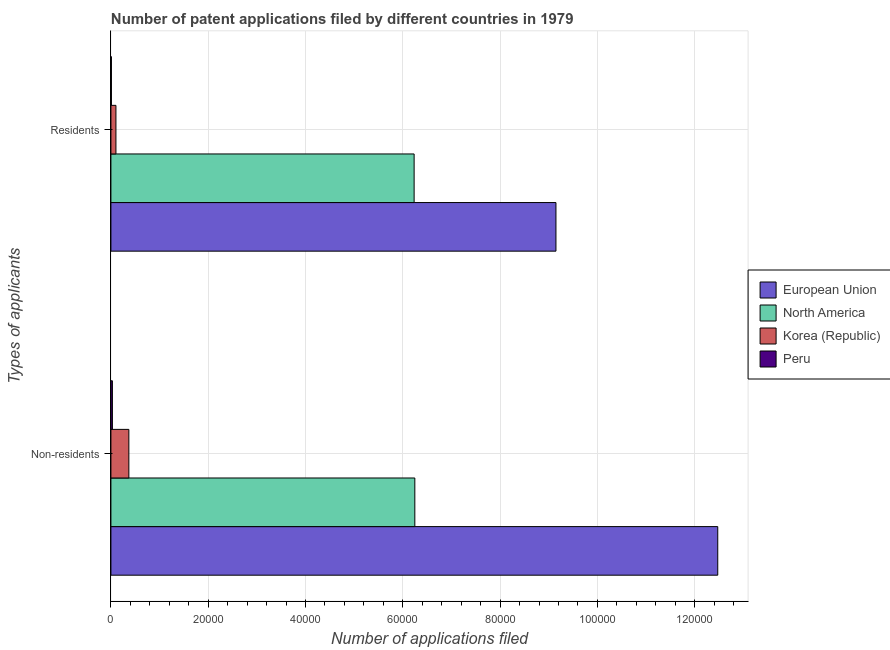Are the number of bars on each tick of the Y-axis equal?
Provide a succinct answer. Yes. How many bars are there on the 2nd tick from the top?
Give a very brief answer. 4. How many bars are there on the 1st tick from the bottom?
Provide a succinct answer. 4. What is the label of the 1st group of bars from the top?
Ensure brevity in your answer.  Residents. What is the number of patent applications by residents in North America?
Ensure brevity in your answer.  6.23e+04. Across all countries, what is the maximum number of patent applications by residents?
Keep it short and to the point. 9.15e+04. Across all countries, what is the minimum number of patent applications by non residents?
Your answer should be very brief. 306. What is the total number of patent applications by non residents in the graph?
Provide a succinct answer. 1.91e+05. What is the difference between the number of patent applications by residents in North America and that in Peru?
Your answer should be very brief. 6.22e+04. What is the difference between the number of patent applications by residents in North America and the number of patent applications by non residents in Korea (Republic)?
Provide a short and direct response. 5.86e+04. What is the average number of patent applications by residents per country?
Keep it short and to the point. 3.87e+04. What is the difference between the number of patent applications by residents and number of patent applications by non residents in Korea (Republic)?
Keep it short and to the point. -2654. In how many countries, is the number of patent applications by non residents greater than 36000 ?
Provide a short and direct response. 2. What is the ratio of the number of patent applications by non residents in North America to that in Korea (Republic)?
Give a very brief answer. 16.94. In how many countries, is the number of patent applications by residents greater than the average number of patent applications by residents taken over all countries?
Keep it short and to the point. 2. What does the 2nd bar from the bottom in Residents represents?
Offer a very short reply. North America. What is the difference between two consecutive major ticks on the X-axis?
Ensure brevity in your answer.  2.00e+04. Are the values on the major ticks of X-axis written in scientific E-notation?
Make the answer very short. No. Does the graph contain any zero values?
Your response must be concise. No. Does the graph contain grids?
Ensure brevity in your answer.  Yes. What is the title of the graph?
Offer a very short reply. Number of patent applications filed by different countries in 1979. What is the label or title of the X-axis?
Keep it short and to the point. Number of applications filed. What is the label or title of the Y-axis?
Your answer should be very brief. Types of applicants. What is the Number of applications filed of European Union in Non-residents?
Provide a short and direct response. 1.25e+05. What is the Number of applications filed of North America in Non-residents?
Keep it short and to the point. 6.25e+04. What is the Number of applications filed in Korea (Republic) in Non-residents?
Make the answer very short. 3688. What is the Number of applications filed of Peru in Non-residents?
Provide a short and direct response. 306. What is the Number of applications filed of European Union in Residents?
Provide a succinct answer. 9.15e+04. What is the Number of applications filed in North America in Residents?
Provide a succinct answer. 6.23e+04. What is the Number of applications filed in Korea (Republic) in Residents?
Ensure brevity in your answer.  1034. What is the Number of applications filed in Peru in Residents?
Keep it short and to the point. 102. Across all Types of applicants, what is the maximum Number of applications filed of European Union?
Provide a succinct answer. 1.25e+05. Across all Types of applicants, what is the maximum Number of applications filed in North America?
Keep it short and to the point. 6.25e+04. Across all Types of applicants, what is the maximum Number of applications filed of Korea (Republic)?
Give a very brief answer. 3688. Across all Types of applicants, what is the maximum Number of applications filed of Peru?
Offer a terse response. 306. Across all Types of applicants, what is the minimum Number of applications filed of European Union?
Provide a succinct answer. 9.15e+04. Across all Types of applicants, what is the minimum Number of applications filed in North America?
Ensure brevity in your answer.  6.23e+04. Across all Types of applicants, what is the minimum Number of applications filed in Korea (Republic)?
Your answer should be very brief. 1034. Across all Types of applicants, what is the minimum Number of applications filed in Peru?
Make the answer very short. 102. What is the total Number of applications filed in European Union in the graph?
Make the answer very short. 2.16e+05. What is the total Number of applications filed of North America in the graph?
Provide a succinct answer. 1.25e+05. What is the total Number of applications filed of Korea (Republic) in the graph?
Ensure brevity in your answer.  4722. What is the total Number of applications filed of Peru in the graph?
Ensure brevity in your answer.  408. What is the difference between the Number of applications filed of European Union in Non-residents and that in Residents?
Your answer should be very brief. 3.33e+04. What is the difference between the Number of applications filed in North America in Non-residents and that in Residents?
Offer a very short reply. 144. What is the difference between the Number of applications filed in Korea (Republic) in Non-residents and that in Residents?
Provide a short and direct response. 2654. What is the difference between the Number of applications filed of Peru in Non-residents and that in Residents?
Your response must be concise. 204. What is the difference between the Number of applications filed in European Union in Non-residents and the Number of applications filed in North America in Residents?
Offer a terse response. 6.24e+04. What is the difference between the Number of applications filed of European Union in Non-residents and the Number of applications filed of Korea (Republic) in Residents?
Make the answer very short. 1.24e+05. What is the difference between the Number of applications filed of European Union in Non-residents and the Number of applications filed of Peru in Residents?
Provide a short and direct response. 1.25e+05. What is the difference between the Number of applications filed in North America in Non-residents and the Number of applications filed in Korea (Republic) in Residents?
Offer a very short reply. 6.14e+04. What is the difference between the Number of applications filed of North America in Non-residents and the Number of applications filed of Peru in Residents?
Offer a very short reply. 6.24e+04. What is the difference between the Number of applications filed in Korea (Republic) in Non-residents and the Number of applications filed in Peru in Residents?
Make the answer very short. 3586. What is the average Number of applications filed of European Union per Types of applicants?
Give a very brief answer. 1.08e+05. What is the average Number of applications filed of North America per Types of applicants?
Offer a very short reply. 6.24e+04. What is the average Number of applications filed of Korea (Republic) per Types of applicants?
Give a very brief answer. 2361. What is the average Number of applications filed of Peru per Types of applicants?
Offer a very short reply. 204. What is the difference between the Number of applications filed of European Union and Number of applications filed of North America in Non-residents?
Provide a succinct answer. 6.23e+04. What is the difference between the Number of applications filed in European Union and Number of applications filed in Korea (Republic) in Non-residents?
Your answer should be compact. 1.21e+05. What is the difference between the Number of applications filed in European Union and Number of applications filed in Peru in Non-residents?
Make the answer very short. 1.24e+05. What is the difference between the Number of applications filed in North America and Number of applications filed in Korea (Republic) in Non-residents?
Offer a very short reply. 5.88e+04. What is the difference between the Number of applications filed of North America and Number of applications filed of Peru in Non-residents?
Your answer should be very brief. 6.22e+04. What is the difference between the Number of applications filed of Korea (Republic) and Number of applications filed of Peru in Non-residents?
Ensure brevity in your answer.  3382. What is the difference between the Number of applications filed of European Union and Number of applications filed of North America in Residents?
Keep it short and to the point. 2.92e+04. What is the difference between the Number of applications filed in European Union and Number of applications filed in Korea (Republic) in Residents?
Make the answer very short. 9.05e+04. What is the difference between the Number of applications filed of European Union and Number of applications filed of Peru in Residents?
Provide a short and direct response. 9.14e+04. What is the difference between the Number of applications filed in North America and Number of applications filed in Korea (Republic) in Residents?
Provide a succinct answer. 6.13e+04. What is the difference between the Number of applications filed of North America and Number of applications filed of Peru in Residents?
Your response must be concise. 6.22e+04. What is the difference between the Number of applications filed in Korea (Republic) and Number of applications filed in Peru in Residents?
Ensure brevity in your answer.  932. What is the ratio of the Number of applications filed of European Union in Non-residents to that in Residents?
Offer a very short reply. 1.36. What is the ratio of the Number of applications filed of Korea (Republic) in Non-residents to that in Residents?
Your response must be concise. 3.57. What is the difference between the highest and the second highest Number of applications filed in European Union?
Ensure brevity in your answer.  3.33e+04. What is the difference between the highest and the second highest Number of applications filed of North America?
Offer a very short reply. 144. What is the difference between the highest and the second highest Number of applications filed of Korea (Republic)?
Keep it short and to the point. 2654. What is the difference between the highest and the second highest Number of applications filed of Peru?
Offer a terse response. 204. What is the difference between the highest and the lowest Number of applications filed in European Union?
Provide a short and direct response. 3.33e+04. What is the difference between the highest and the lowest Number of applications filed of North America?
Provide a short and direct response. 144. What is the difference between the highest and the lowest Number of applications filed of Korea (Republic)?
Make the answer very short. 2654. What is the difference between the highest and the lowest Number of applications filed in Peru?
Your answer should be very brief. 204. 